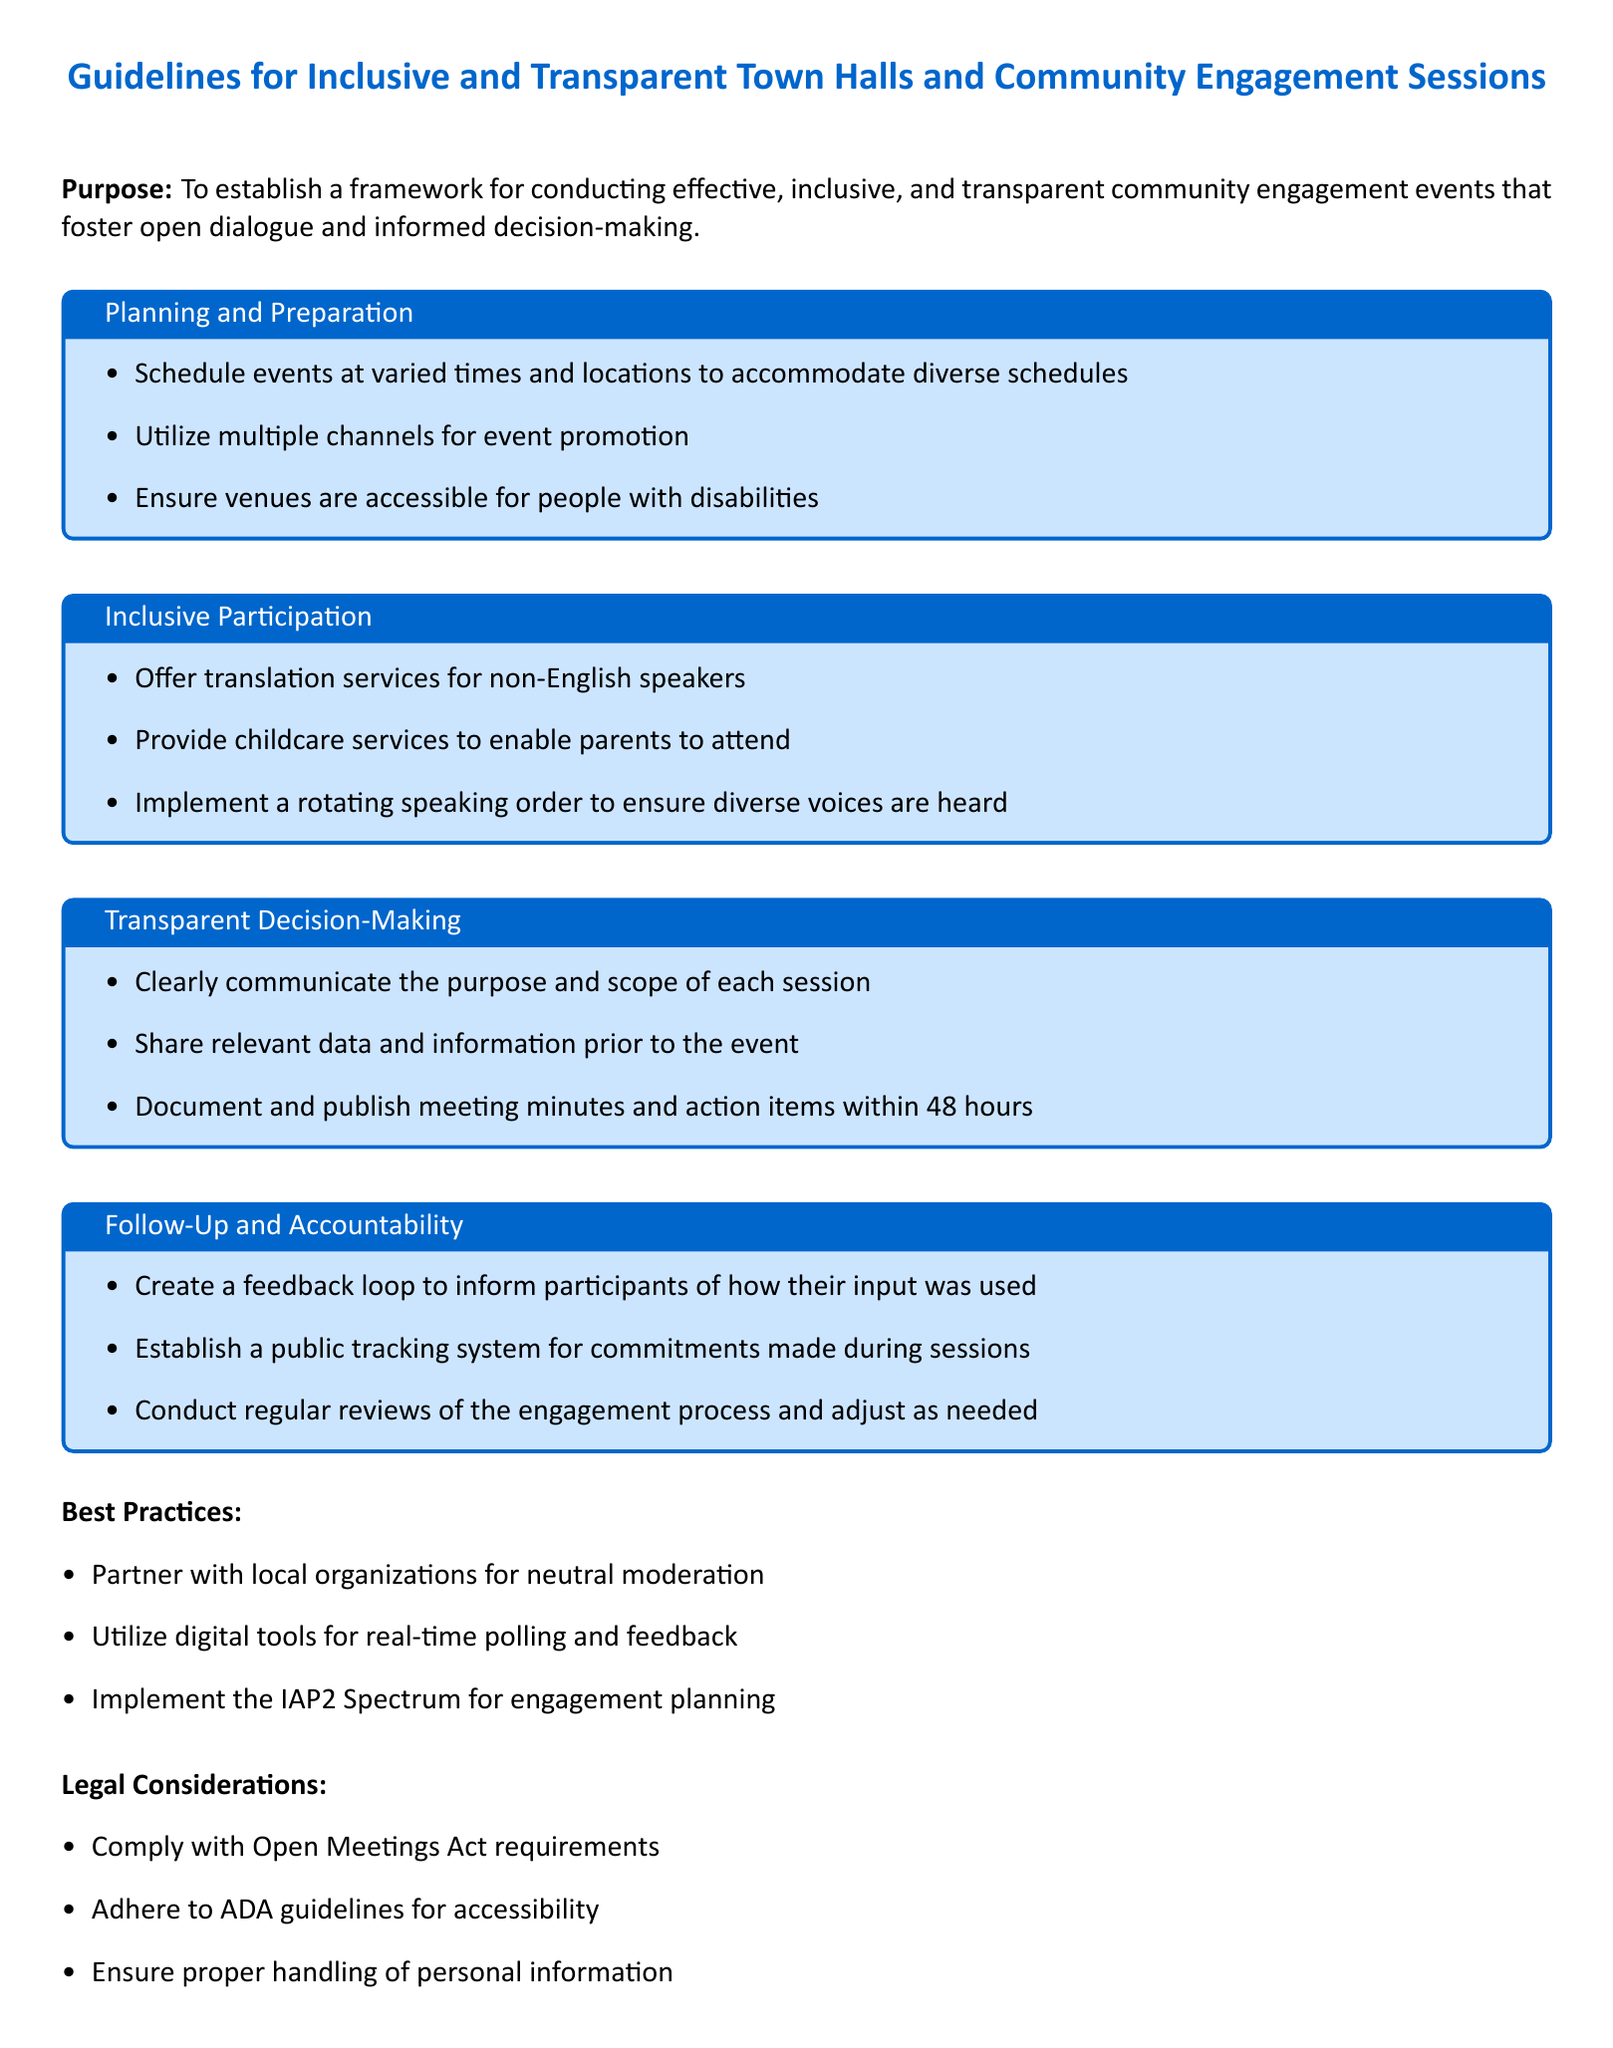What is the purpose of the guidelines? The purpose is to establish a framework for conducting effective, inclusive, and transparent community engagement events that foster open dialogue and informed decision-making.
Answer: To establish a framework for conducting effective, inclusive, and transparent community engagement events What is one of the items listed under Planning and Preparation? Items listed under Planning and Preparation include scheduling events at varied times.
Answer: Schedule events at varied times What service is recommended for non-English speakers? The document recommends offering translation services for non-English speakers as part of inclusive participation.
Answer: Translation services What is one of the requirements for Transparent Decision-Making? One requirement is to clearly communicate the purpose and scope of each session.
Answer: Clearly communicate the purpose and scope What feedback mechanism is mentioned under Follow-Up and Accountability? The document states to create a feedback loop to inform participants of how their input was used.
Answer: Create a feedback loop What legal framework must be complied with according to the document? The Open Meetings Act is mentioned as a legal requirement that must be complied with.
Answer: Open Meetings Act What should be established for tracking commitments made during sessions? A public tracking system for commitments made during sessions should be established.
Answer: Public tracking system What is the document type? The document is a set of guidelines.
Answer: Guidelines What partnership is suggested for neutral moderation? The guidelines suggest partnering with local organizations for neutral moderation.
Answer: Local organizations 